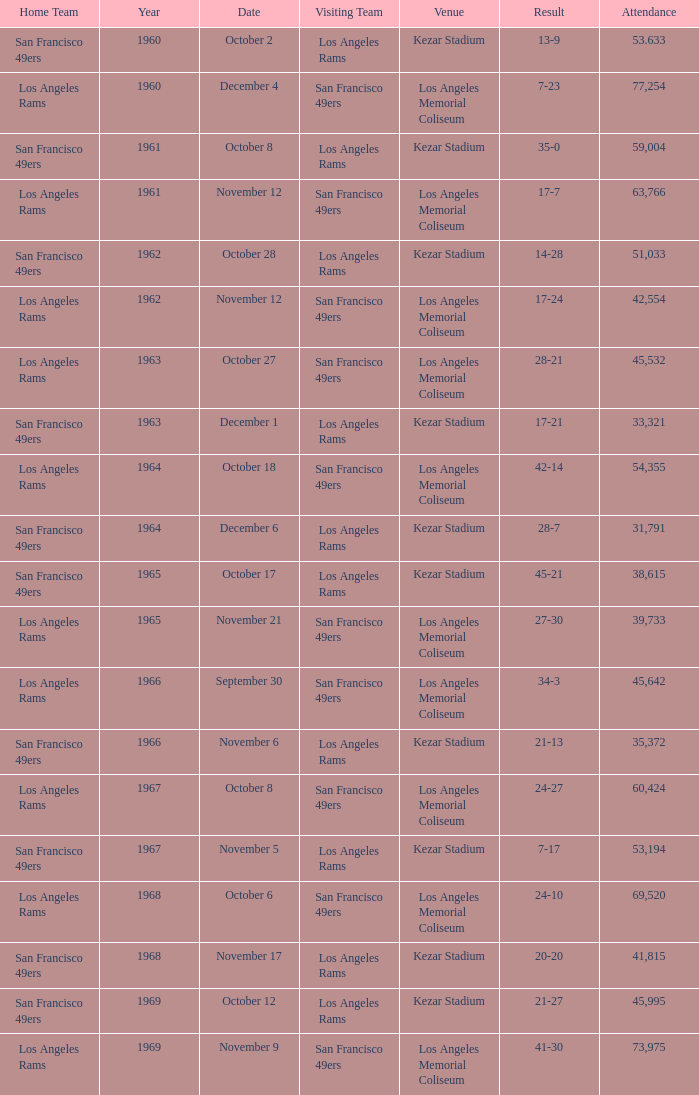When was the earliest year when the attendance was 77,254? 1960.0. 